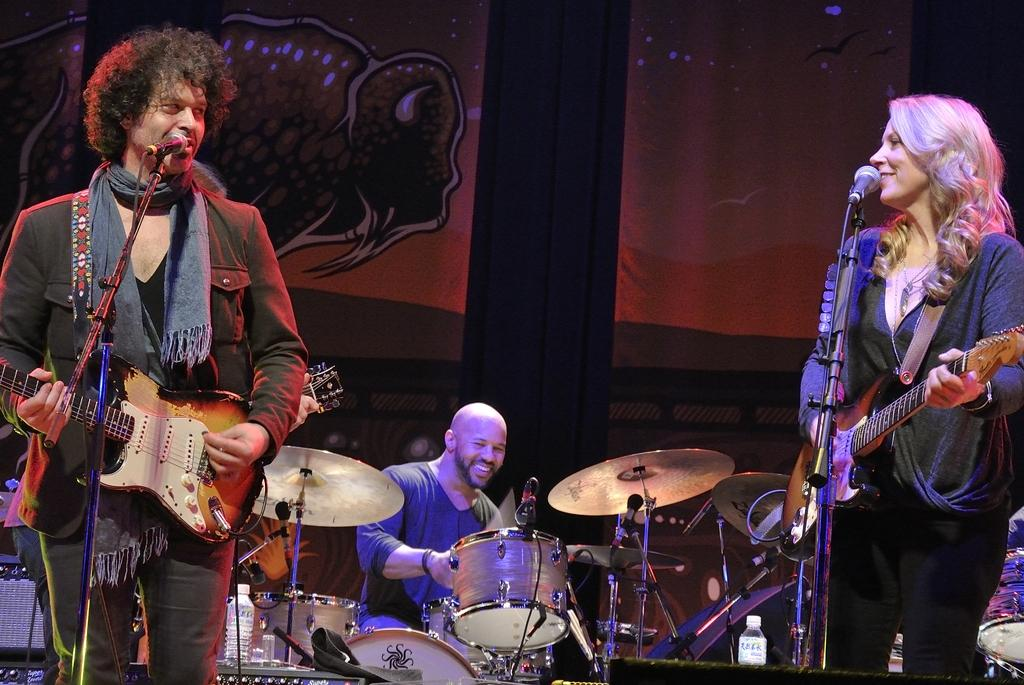What are the two people in the image doing? There is a man playing guitar and a woman playing guitar in the image. What is in front of the guitar players? A microphone is present in front of the guitar players. What other instrument can be seen being played in the image? There is a man playing drums in the background of the image. What type of territory is depicted in the image? There is no territory depicted in the image; it features two guitar players, a microphone, and a drummer. How many giants are present in the image? There are no giants present in the image. 